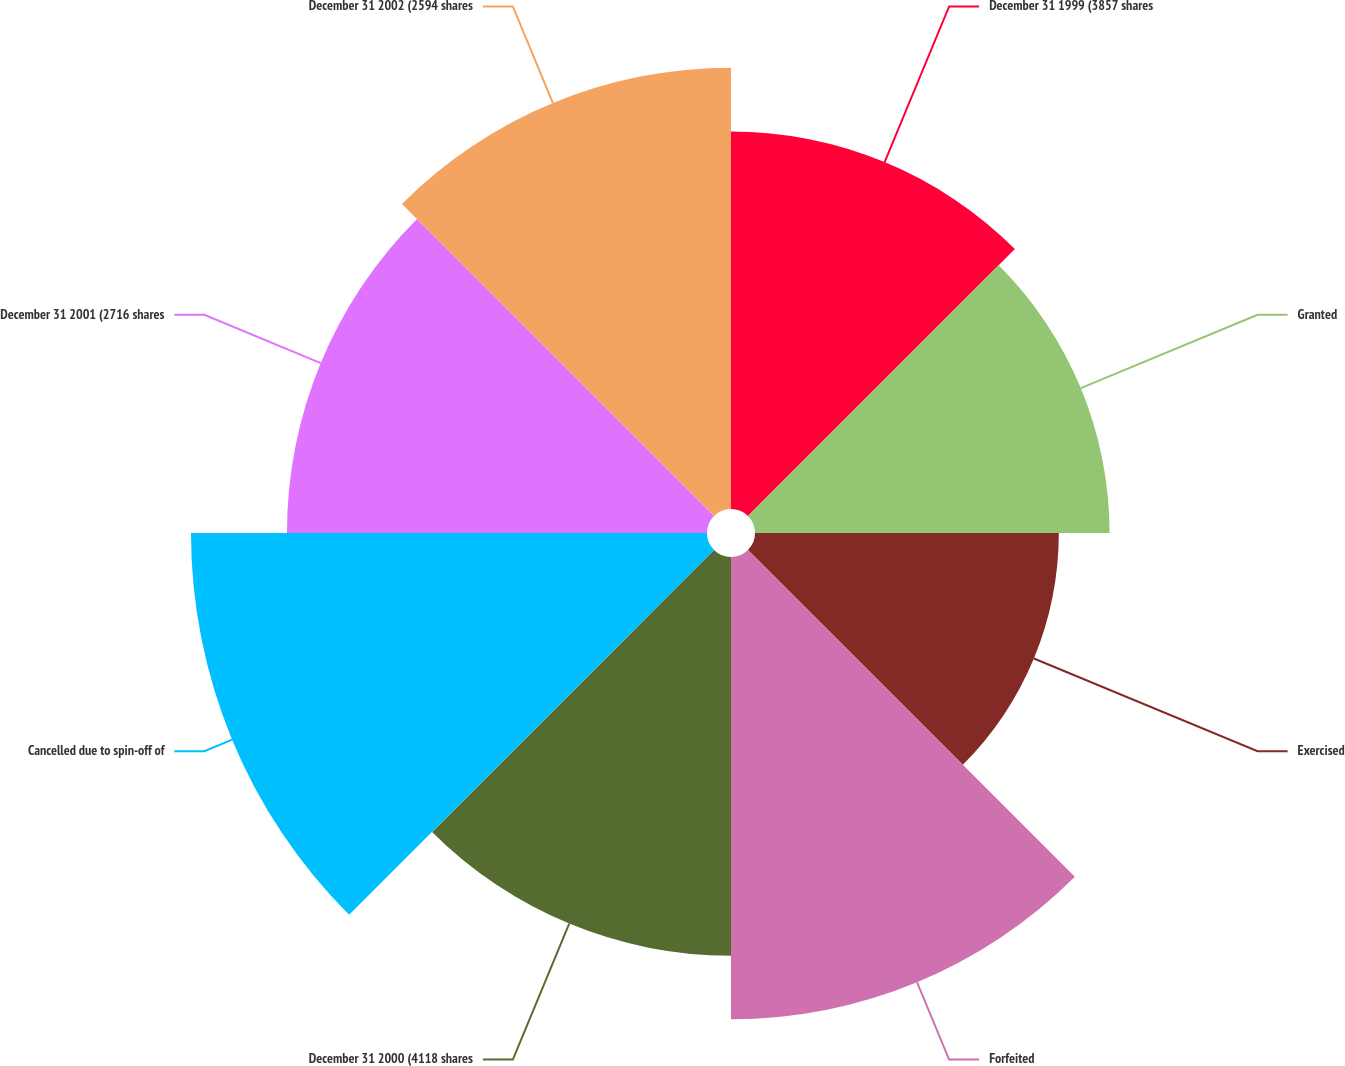Convert chart to OTSL. <chart><loc_0><loc_0><loc_500><loc_500><pie_chart><fcel>December 31 1999 (3857 shares<fcel>Granted<fcel>Exercised<fcel>Forfeited<fcel>December 31 2000 (4118 shares<fcel>Cancelled due to spin-off of<fcel>December 31 2001 (2716 shares<fcel>December 31 2002 (2594 shares<nl><fcel>11.53%<fcel>10.83%<fcel>9.28%<fcel>14.12%<fcel>12.18%<fcel>15.76%<fcel>12.83%<fcel>13.48%<nl></chart> 